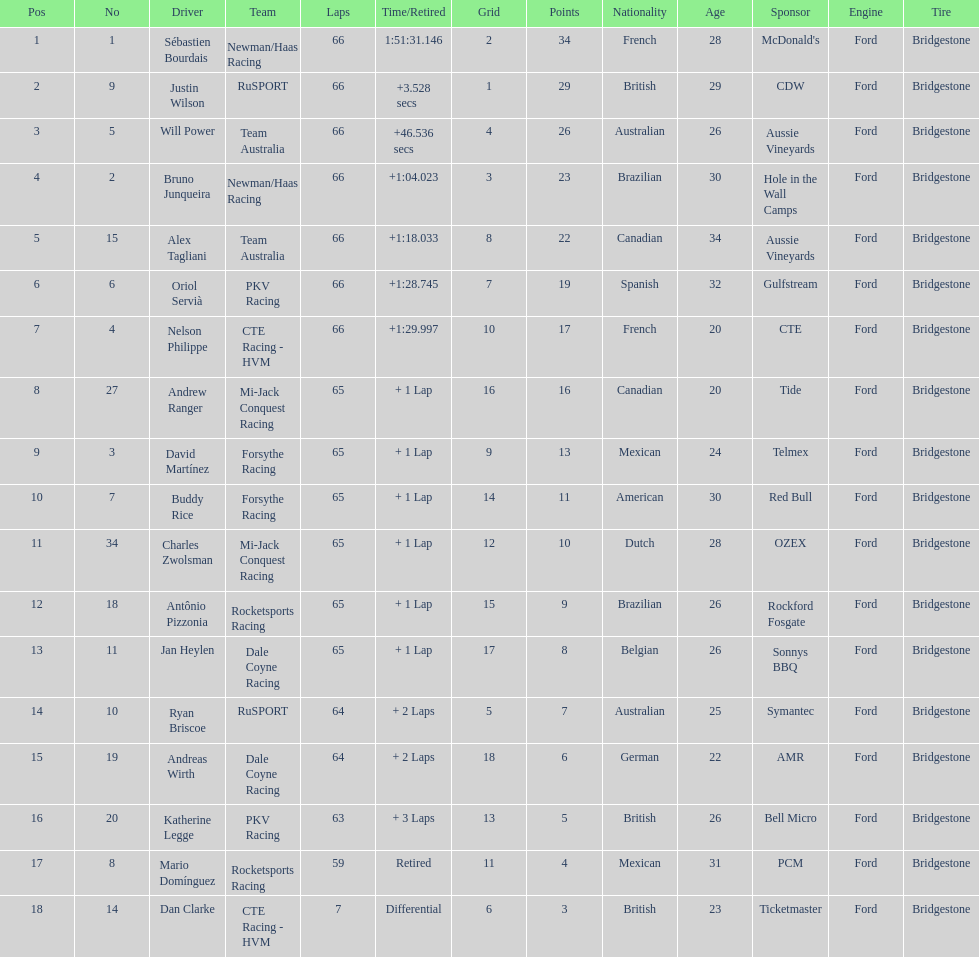How many drivers were unable to surpass 60 laps? 2. 